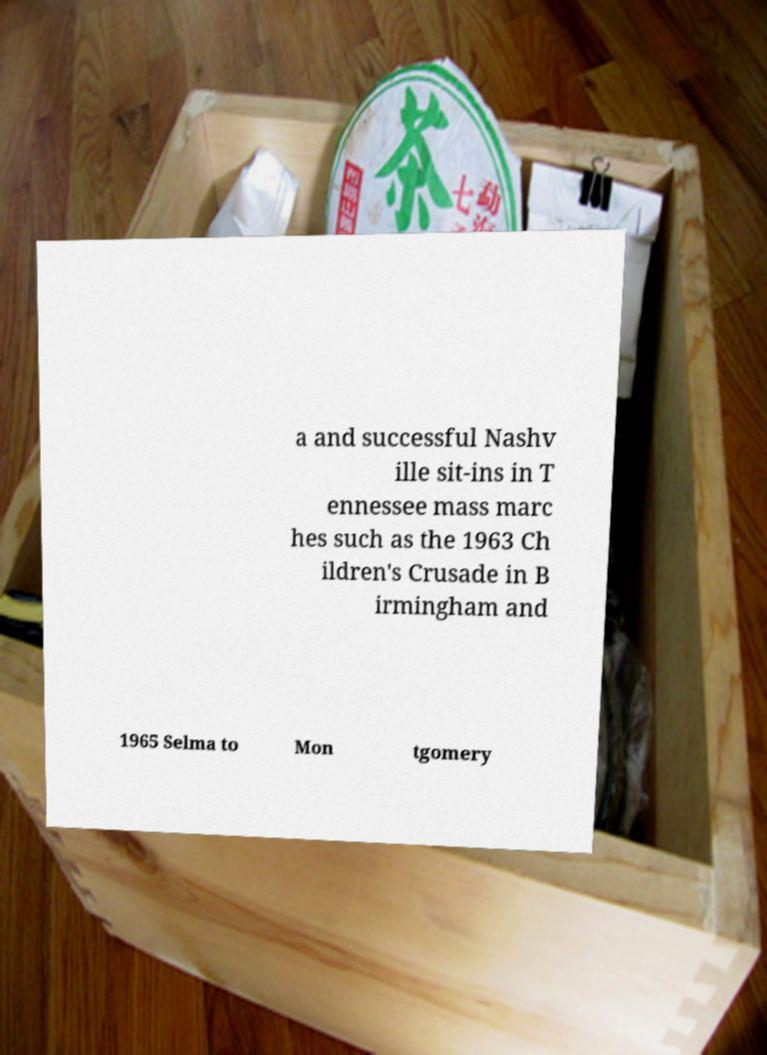There's text embedded in this image that I need extracted. Can you transcribe it verbatim? a and successful Nashv ille sit-ins in T ennessee mass marc hes such as the 1963 Ch ildren's Crusade in B irmingham and 1965 Selma to Mon tgomery 